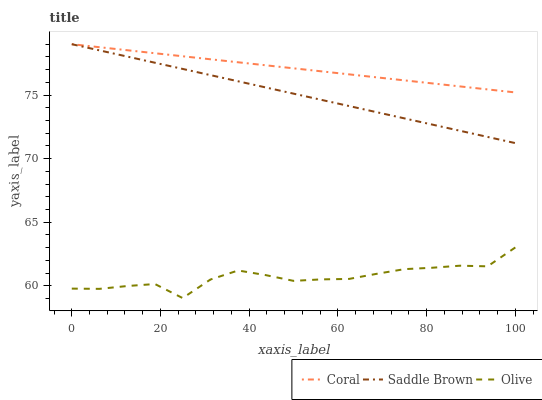Does Olive have the minimum area under the curve?
Answer yes or no. Yes. Does Coral have the maximum area under the curve?
Answer yes or no. Yes. Does Saddle Brown have the minimum area under the curve?
Answer yes or no. No. Does Saddle Brown have the maximum area under the curve?
Answer yes or no. No. Is Saddle Brown the smoothest?
Answer yes or no. Yes. Is Olive the roughest?
Answer yes or no. Yes. Is Coral the smoothest?
Answer yes or no. No. Is Coral the roughest?
Answer yes or no. No. Does Olive have the lowest value?
Answer yes or no. Yes. Does Saddle Brown have the lowest value?
Answer yes or no. No. Does Saddle Brown have the highest value?
Answer yes or no. Yes. Is Olive less than Coral?
Answer yes or no. Yes. Is Saddle Brown greater than Olive?
Answer yes or no. Yes. Does Saddle Brown intersect Coral?
Answer yes or no. Yes. Is Saddle Brown less than Coral?
Answer yes or no. No. Is Saddle Brown greater than Coral?
Answer yes or no. No. Does Olive intersect Coral?
Answer yes or no. No. 